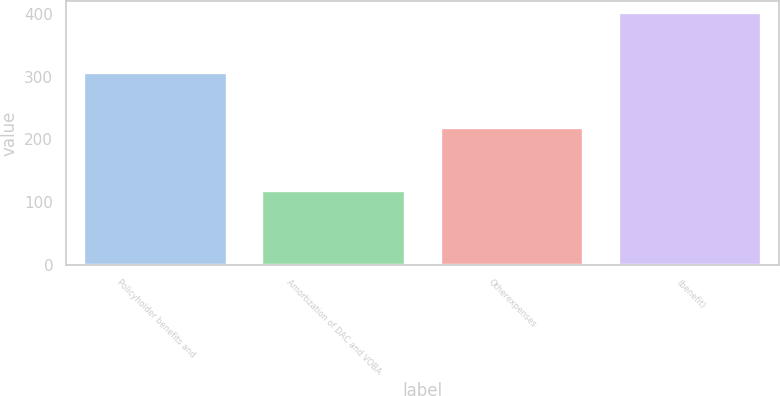Convert chart to OTSL. <chart><loc_0><loc_0><loc_500><loc_500><bar_chart><fcel>Policyholder benefits and<fcel>Amortization of DAC and VOBA<fcel>Otherexpenses<fcel>(benefit)<nl><fcel>306<fcel>118<fcel>219<fcel>401<nl></chart> 